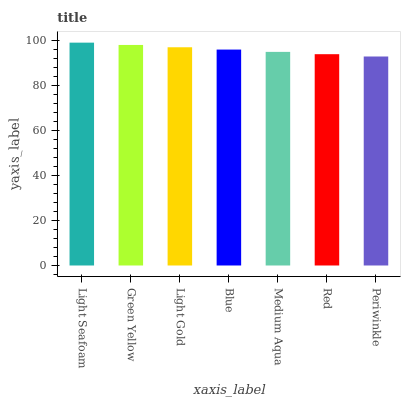Is Periwinkle the minimum?
Answer yes or no. Yes. Is Light Seafoam the maximum?
Answer yes or no. Yes. Is Green Yellow the minimum?
Answer yes or no. No. Is Green Yellow the maximum?
Answer yes or no. No. Is Light Seafoam greater than Green Yellow?
Answer yes or no. Yes. Is Green Yellow less than Light Seafoam?
Answer yes or no. Yes. Is Green Yellow greater than Light Seafoam?
Answer yes or no. No. Is Light Seafoam less than Green Yellow?
Answer yes or no. No. Is Blue the high median?
Answer yes or no. Yes. Is Blue the low median?
Answer yes or no. Yes. Is Periwinkle the high median?
Answer yes or no. No. Is Green Yellow the low median?
Answer yes or no. No. 